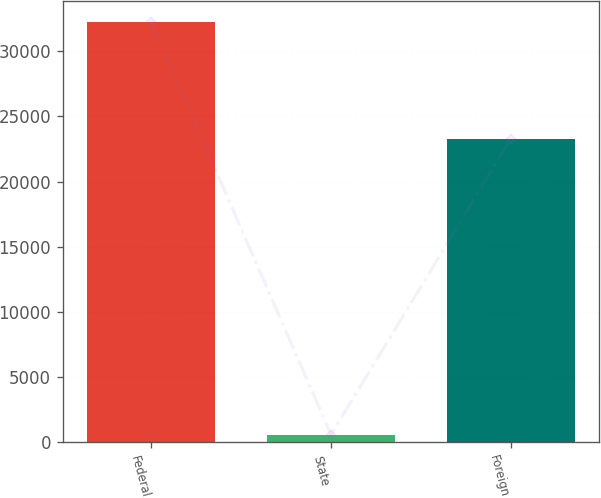<chart> <loc_0><loc_0><loc_500><loc_500><bar_chart><fcel>Federal<fcel>State<fcel>Foreign<nl><fcel>32222<fcel>581<fcel>23304<nl></chart> 